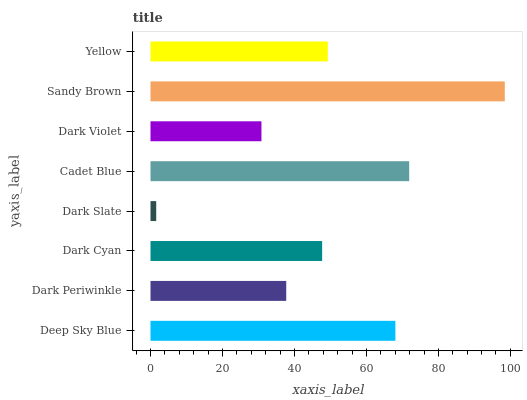Is Dark Slate the minimum?
Answer yes or no. Yes. Is Sandy Brown the maximum?
Answer yes or no. Yes. Is Dark Periwinkle the minimum?
Answer yes or no. No. Is Dark Periwinkle the maximum?
Answer yes or no. No. Is Deep Sky Blue greater than Dark Periwinkle?
Answer yes or no. Yes. Is Dark Periwinkle less than Deep Sky Blue?
Answer yes or no. Yes. Is Dark Periwinkle greater than Deep Sky Blue?
Answer yes or no. No. Is Deep Sky Blue less than Dark Periwinkle?
Answer yes or no. No. Is Yellow the high median?
Answer yes or no. Yes. Is Dark Cyan the low median?
Answer yes or no. Yes. Is Dark Periwinkle the high median?
Answer yes or no. No. Is Dark Violet the low median?
Answer yes or no. No. 